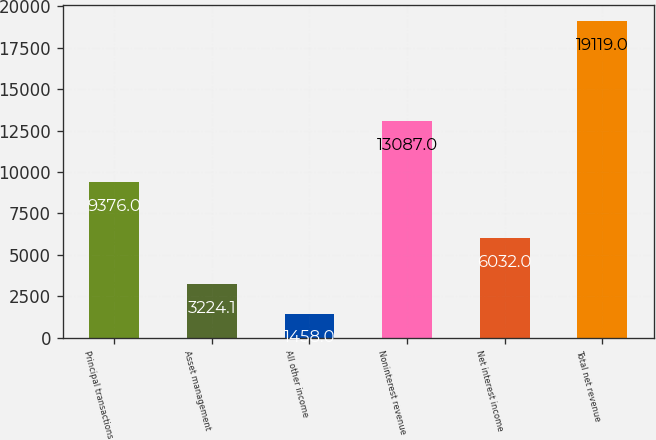<chart> <loc_0><loc_0><loc_500><loc_500><bar_chart><fcel>Principal transactions<fcel>Asset management<fcel>All other income<fcel>Noninterest revenue<fcel>Net interest income<fcel>Total net revenue<nl><fcel>9376<fcel>3224.1<fcel>1458<fcel>13087<fcel>6032<fcel>19119<nl></chart> 